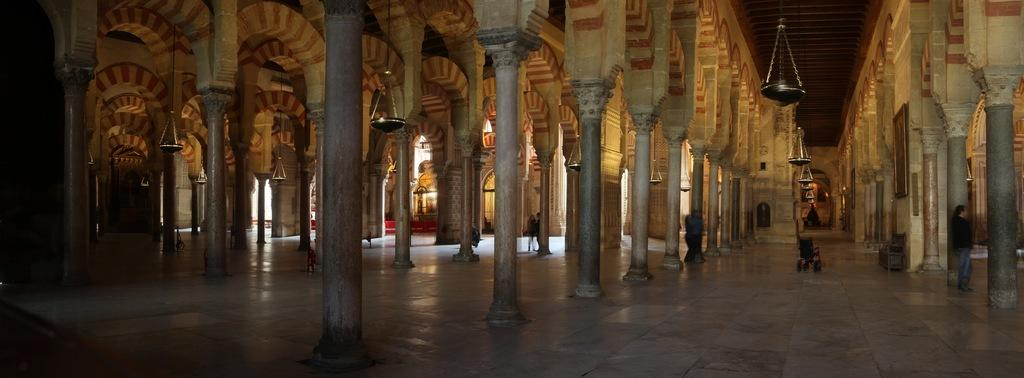What architectural features are present in the foreground of the hall? There are arches and pillars in the foreground of the hall. What can be seen hanging from the ceiling in the hall? There are bowls or similar objects hanging from the ceiling. What is happening on the floor of the hall? There are people walking on the floor. What type of interest is being paid by the goldfish in the image? There are no goldfish present in the image, so it is not possible to determine what type of interest they might be paying. 